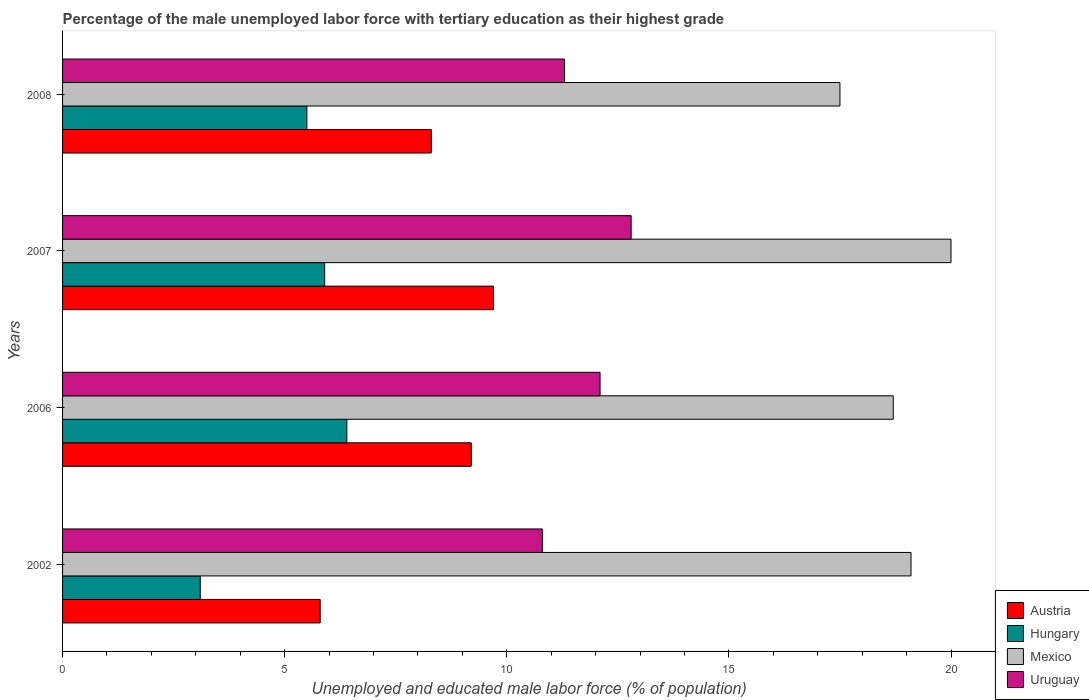How many groups of bars are there?
Keep it short and to the point. 4. Are the number of bars on each tick of the Y-axis equal?
Offer a very short reply. Yes. How many bars are there on the 4th tick from the bottom?
Your response must be concise. 4. What is the percentage of the unemployed male labor force with tertiary education in Hungary in 2007?
Offer a terse response. 5.9. Across all years, what is the maximum percentage of the unemployed male labor force with tertiary education in Uruguay?
Your answer should be very brief. 12.8. What is the difference between the percentage of the unemployed male labor force with tertiary education in Uruguay in 2007 and that in 2008?
Your response must be concise. 1.5. What is the difference between the percentage of the unemployed male labor force with tertiary education in Uruguay in 2008 and the percentage of the unemployed male labor force with tertiary education in Austria in 2007?
Offer a very short reply. 1.6. What is the average percentage of the unemployed male labor force with tertiary education in Mexico per year?
Give a very brief answer. 18.83. In the year 2006, what is the difference between the percentage of the unemployed male labor force with tertiary education in Uruguay and percentage of the unemployed male labor force with tertiary education in Hungary?
Your response must be concise. 5.7. What is the ratio of the percentage of the unemployed male labor force with tertiary education in Uruguay in 2002 to that in 2006?
Offer a terse response. 0.89. Is the percentage of the unemployed male labor force with tertiary education in Austria in 2002 less than that in 2007?
Ensure brevity in your answer.  Yes. What is the difference between the highest and the second highest percentage of the unemployed male labor force with tertiary education in Mexico?
Provide a short and direct response. 0.9. What is the difference between the highest and the lowest percentage of the unemployed male labor force with tertiary education in Hungary?
Give a very brief answer. 3.3. What does the 3rd bar from the top in 2006 represents?
Offer a terse response. Hungary. Is it the case that in every year, the sum of the percentage of the unemployed male labor force with tertiary education in Uruguay and percentage of the unemployed male labor force with tertiary education in Mexico is greater than the percentage of the unemployed male labor force with tertiary education in Austria?
Your answer should be compact. Yes. Are all the bars in the graph horizontal?
Keep it short and to the point. Yes. How many years are there in the graph?
Your response must be concise. 4. Does the graph contain any zero values?
Offer a very short reply. No. Does the graph contain grids?
Provide a short and direct response. No. Where does the legend appear in the graph?
Your response must be concise. Bottom right. How many legend labels are there?
Offer a very short reply. 4. How are the legend labels stacked?
Ensure brevity in your answer.  Vertical. What is the title of the graph?
Your answer should be compact. Percentage of the male unemployed labor force with tertiary education as their highest grade. Does "Gambia, The" appear as one of the legend labels in the graph?
Your answer should be compact. No. What is the label or title of the X-axis?
Offer a terse response. Unemployed and educated male labor force (% of population). What is the label or title of the Y-axis?
Make the answer very short. Years. What is the Unemployed and educated male labor force (% of population) in Austria in 2002?
Your response must be concise. 5.8. What is the Unemployed and educated male labor force (% of population) of Hungary in 2002?
Offer a terse response. 3.1. What is the Unemployed and educated male labor force (% of population) in Mexico in 2002?
Give a very brief answer. 19.1. What is the Unemployed and educated male labor force (% of population) of Uruguay in 2002?
Keep it short and to the point. 10.8. What is the Unemployed and educated male labor force (% of population) in Austria in 2006?
Provide a succinct answer. 9.2. What is the Unemployed and educated male labor force (% of population) in Hungary in 2006?
Offer a very short reply. 6.4. What is the Unemployed and educated male labor force (% of population) in Mexico in 2006?
Give a very brief answer. 18.7. What is the Unemployed and educated male labor force (% of population) in Uruguay in 2006?
Provide a succinct answer. 12.1. What is the Unemployed and educated male labor force (% of population) in Austria in 2007?
Offer a very short reply. 9.7. What is the Unemployed and educated male labor force (% of population) of Hungary in 2007?
Ensure brevity in your answer.  5.9. What is the Unemployed and educated male labor force (% of population) of Mexico in 2007?
Make the answer very short. 20. What is the Unemployed and educated male labor force (% of population) of Uruguay in 2007?
Offer a terse response. 12.8. What is the Unemployed and educated male labor force (% of population) in Austria in 2008?
Make the answer very short. 8.3. What is the Unemployed and educated male labor force (% of population) of Hungary in 2008?
Your answer should be compact. 5.5. What is the Unemployed and educated male labor force (% of population) of Mexico in 2008?
Make the answer very short. 17.5. What is the Unemployed and educated male labor force (% of population) in Uruguay in 2008?
Your answer should be very brief. 11.3. Across all years, what is the maximum Unemployed and educated male labor force (% of population) in Austria?
Provide a short and direct response. 9.7. Across all years, what is the maximum Unemployed and educated male labor force (% of population) in Hungary?
Offer a very short reply. 6.4. Across all years, what is the maximum Unemployed and educated male labor force (% of population) in Mexico?
Ensure brevity in your answer.  20. Across all years, what is the maximum Unemployed and educated male labor force (% of population) in Uruguay?
Provide a short and direct response. 12.8. Across all years, what is the minimum Unemployed and educated male labor force (% of population) in Austria?
Ensure brevity in your answer.  5.8. Across all years, what is the minimum Unemployed and educated male labor force (% of population) in Hungary?
Keep it short and to the point. 3.1. Across all years, what is the minimum Unemployed and educated male labor force (% of population) of Mexico?
Your answer should be compact. 17.5. Across all years, what is the minimum Unemployed and educated male labor force (% of population) of Uruguay?
Your answer should be very brief. 10.8. What is the total Unemployed and educated male labor force (% of population) of Hungary in the graph?
Keep it short and to the point. 20.9. What is the total Unemployed and educated male labor force (% of population) of Mexico in the graph?
Your response must be concise. 75.3. What is the total Unemployed and educated male labor force (% of population) of Uruguay in the graph?
Ensure brevity in your answer.  47. What is the difference between the Unemployed and educated male labor force (% of population) in Mexico in 2002 and that in 2006?
Offer a very short reply. 0.4. What is the difference between the Unemployed and educated male labor force (% of population) in Uruguay in 2002 and that in 2006?
Make the answer very short. -1.3. What is the difference between the Unemployed and educated male labor force (% of population) of Austria in 2002 and that in 2007?
Your answer should be very brief. -3.9. What is the difference between the Unemployed and educated male labor force (% of population) in Mexico in 2002 and that in 2007?
Your response must be concise. -0.9. What is the difference between the Unemployed and educated male labor force (% of population) in Austria in 2002 and that in 2008?
Your answer should be very brief. -2.5. What is the difference between the Unemployed and educated male labor force (% of population) of Hungary in 2002 and that in 2008?
Make the answer very short. -2.4. What is the difference between the Unemployed and educated male labor force (% of population) of Mexico in 2002 and that in 2008?
Your answer should be compact. 1.6. What is the difference between the Unemployed and educated male labor force (% of population) in Mexico in 2006 and that in 2007?
Your response must be concise. -1.3. What is the difference between the Unemployed and educated male labor force (% of population) of Uruguay in 2006 and that in 2007?
Provide a succinct answer. -0.7. What is the difference between the Unemployed and educated male labor force (% of population) in Hungary in 2006 and that in 2008?
Your answer should be very brief. 0.9. What is the difference between the Unemployed and educated male labor force (% of population) in Mexico in 2006 and that in 2008?
Ensure brevity in your answer.  1.2. What is the difference between the Unemployed and educated male labor force (% of population) of Austria in 2007 and that in 2008?
Make the answer very short. 1.4. What is the difference between the Unemployed and educated male labor force (% of population) in Mexico in 2007 and that in 2008?
Offer a very short reply. 2.5. What is the difference between the Unemployed and educated male labor force (% of population) of Uruguay in 2007 and that in 2008?
Give a very brief answer. 1.5. What is the difference between the Unemployed and educated male labor force (% of population) in Austria in 2002 and the Unemployed and educated male labor force (% of population) in Mexico in 2006?
Provide a short and direct response. -12.9. What is the difference between the Unemployed and educated male labor force (% of population) in Hungary in 2002 and the Unemployed and educated male labor force (% of population) in Mexico in 2006?
Your answer should be very brief. -15.6. What is the difference between the Unemployed and educated male labor force (% of population) of Austria in 2002 and the Unemployed and educated male labor force (% of population) of Hungary in 2007?
Provide a short and direct response. -0.1. What is the difference between the Unemployed and educated male labor force (% of population) of Hungary in 2002 and the Unemployed and educated male labor force (% of population) of Mexico in 2007?
Your answer should be compact. -16.9. What is the difference between the Unemployed and educated male labor force (% of population) in Hungary in 2002 and the Unemployed and educated male labor force (% of population) in Uruguay in 2007?
Your response must be concise. -9.7. What is the difference between the Unemployed and educated male labor force (% of population) in Mexico in 2002 and the Unemployed and educated male labor force (% of population) in Uruguay in 2007?
Your answer should be compact. 6.3. What is the difference between the Unemployed and educated male labor force (% of population) of Hungary in 2002 and the Unemployed and educated male labor force (% of population) of Mexico in 2008?
Provide a succinct answer. -14.4. What is the difference between the Unemployed and educated male labor force (% of population) of Hungary in 2002 and the Unemployed and educated male labor force (% of population) of Uruguay in 2008?
Ensure brevity in your answer.  -8.2. What is the difference between the Unemployed and educated male labor force (% of population) in Austria in 2006 and the Unemployed and educated male labor force (% of population) in Uruguay in 2007?
Provide a short and direct response. -3.6. What is the difference between the Unemployed and educated male labor force (% of population) of Hungary in 2006 and the Unemployed and educated male labor force (% of population) of Mexico in 2007?
Provide a short and direct response. -13.6. What is the difference between the Unemployed and educated male labor force (% of population) in Hungary in 2006 and the Unemployed and educated male labor force (% of population) in Uruguay in 2008?
Give a very brief answer. -4.9. What is the difference between the Unemployed and educated male labor force (% of population) in Mexico in 2006 and the Unemployed and educated male labor force (% of population) in Uruguay in 2008?
Your answer should be very brief. 7.4. What is the difference between the Unemployed and educated male labor force (% of population) in Austria in 2007 and the Unemployed and educated male labor force (% of population) in Hungary in 2008?
Offer a terse response. 4.2. What is the difference between the Unemployed and educated male labor force (% of population) of Austria in 2007 and the Unemployed and educated male labor force (% of population) of Mexico in 2008?
Provide a short and direct response. -7.8. What is the difference between the Unemployed and educated male labor force (% of population) of Hungary in 2007 and the Unemployed and educated male labor force (% of population) of Uruguay in 2008?
Your answer should be compact. -5.4. What is the difference between the Unemployed and educated male labor force (% of population) of Mexico in 2007 and the Unemployed and educated male labor force (% of population) of Uruguay in 2008?
Offer a terse response. 8.7. What is the average Unemployed and educated male labor force (% of population) of Austria per year?
Make the answer very short. 8.25. What is the average Unemployed and educated male labor force (% of population) in Hungary per year?
Offer a terse response. 5.22. What is the average Unemployed and educated male labor force (% of population) of Mexico per year?
Ensure brevity in your answer.  18.82. What is the average Unemployed and educated male labor force (% of population) in Uruguay per year?
Provide a succinct answer. 11.75. In the year 2002, what is the difference between the Unemployed and educated male labor force (% of population) of Austria and Unemployed and educated male labor force (% of population) of Uruguay?
Ensure brevity in your answer.  -5. In the year 2002, what is the difference between the Unemployed and educated male labor force (% of population) of Mexico and Unemployed and educated male labor force (% of population) of Uruguay?
Offer a terse response. 8.3. In the year 2006, what is the difference between the Unemployed and educated male labor force (% of population) in Austria and Unemployed and educated male labor force (% of population) in Mexico?
Ensure brevity in your answer.  -9.5. In the year 2006, what is the difference between the Unemployed and educated male labor force (% of population) in Hungary and Unemployed and educated male labor force (% of population) in Uruguay?
Your response must be concise. -5.7. In the year 2006, what is the difference between the Unemployed and educated male labor force (% of population) of Mexico and Unemployed and educated male labor force (% of population) of Uruguay?
Your answer should be compact. 6.6. In the year 2007, what is the difference between the Unemployed and educated male labor force (% of population) of Austria and Unemployed and educated male labor force (% of population) of Hungary?
Your answer should be very brief. 3.8. In the year 2007, what is the difference between the Unemployed and educated male labor force (% of population) in Austria and Unemployed and educated male labor force (% of population) in Mexico?
Provide a short and direct response. -10.3. In the year 2007, what is the difference between the Unemployed and educated male labor force (% of population) in Hungary and Unemployed and educated male labor force (% of population) in Mexico?
Your answer should be very brief. -14.1. In the year 2007, what is the difference between the Unemployed and educated male labor force (% of population) of Hungary and Unemployed and educated male labor force (% of population) of Uruguay?
Make the answer very short. -6.9. In the year 2008, what is the difference between the Unemployed and educated male labor force (% of population) of Austria and Unemployed and educated male labor force (% of population) of Mexico?
Provide a succinct answer. -9.2. In the year 2008, what is the difference between the Unemployed and educated male labor force (% of population) of Hungary and Unemployed and educated male labor force (% of population) of Mexico?
Give a very brief answer. -12. In the year 2008, what is the difference between the Unemployed and educated male labor force (% of population) of Hungary and Unemployed and educated male labor force (% of population) of Uruguay?
Give a very brief answer. -5.8. What is the ratio of the Unemployed and educated male labor force (% of population) of Austria in 2002 to that in 2006?
Keep it short and to the point. 0.63. What is the ratio of the Unemployed and educated male labor force (% of population) in Hungary in 2002 to that in 2006?
Offer a very short reply. 0.48. What is the ratio of the Unemployed and educated male labor force (% of population) of Mexico in 2002 to that in 2006?
Keep it short and to the point. 1.02. What is the ratio of the Unemployed and educated male labor force (% of population) of Uruguay in 2002 to that in 2006?
Make the answer very short. 0.89. What is the ratio of the Unemployed and educated male labor force (% of population) of Austria in 2002 to that in 2007?
Give a very brief answer. 0.6. What is the ratio of the Unemployed and educated male labor force (% of population) in Hungary in 2002 to that in 2007?
Your response must be concise. 0.53. What is the ratio of the Unemployed and educated male labor force (% of population) in Mexico in 2002 to that in 2007?
Your answer should be very brief. 0.95. What is the ratio of the Unemployed and educated male labor force (% of population) in Uruguay in 2002 to that in 2007?
Your answer should be compact. 0.84. What is the ratio of the Unemployed and educated male labor force (% of population) in Austria in 2002 to that in 2008?
Your answer should be very brief. 0.7. What is the ratio of the Unemployed and educated male labor force (% of population) in Hungary in 2002 to that in 2008?
Your answer should be very brief. 0.56. What is the ratio of the Unemployed and educated male labor force (% of population) in Mexico in 2002 to that in 2008?
Provide a succinct answer. 1.09. What is the ratio of the Unemployed and educated male labor force (% of population) of Uruguay in 2002 to that in 2008?
Ensure brevity in your answer.  0.96. What is the ratio of the Unemployed and educated male labor force (% of population) in Austria in 2006 to that in 2007?
Provide a succinct answer. 0.95. What is the ratio of the Unemployed and educated male labor force (% of population) of Hungary in 2006 to that in 2007?
Offer a terse response. 1.08. What is the ratio of the Unemployed and educated male labor force (% of population) in Mexico in 2006 to that in 2007?
Keep it short and to the point. 0.94. What is the ratio of the Unemployed and educated male labor force (% of population) in Uruguay in 2006 to that in 2007?
Ensure brevity in your answer.  0.95. What is the ratio of the Unemployed and educated male labor force (% of population) in Austria in 2006 to that in 2008?
Provide a short and direct response. 1.11. What is the ratio of the Unemployed and educated male labor force (% of population) in Hungary in 2006 to that in 2008?
Give a very brief answer. 1.16. What is the ratio of the Unemployed and educated male labor force (% of population) of Mexico in 2006 to that in 2008?
Ensure brevity in your answer.  1.07. What is the ratio of the Unemployed and educated male labor force (% of population) of Uruguay in 2006 to that in 2008?
Offer a terse response. 1.07. What is the ratio of the Unemployed and educated male labor force (% of population) of Austria in 2007 to that in 2008?
Your answer should be compact. 1.17. What is the ratio of the Unemployed and educated male labor force (% of population) of Hungary in 2007 to that in 2008?
Your answer should be compact. 1.07. What is the ratio of the Unemployed and educated male labor force (% of population) in Mexico in 2007 to that in 2008?
Offer a very short reply. 1.14. What is the ratio of the Unemployed and educated male labor force (% of population) in Uruguay in 2007 to that in 2008?
Provide a short and direct response. 1.13. What is the difference between the highest and the second highest Unemployed and educated male labor force (% of population) in Austria?
Provide a short and direct response. 0.5. What is the difference between the highest and the second highest Unemployed and educated male labor force (% of population) of Hungary?
Make the answer very short. 0.5. What is the difference between the highest and the second highest Unemployed and educated male labor force (% of population) in Mexico?
Your response must be concise. 0.9. What is the difference between the highest and the second highest Unemployed and educated male labor force (% of population) in Uruguay?
Offer a very short reply. 0.7. What is the difference between the highest and the lowest Unemployed and educated male labor force (% of population) in Austria?
Your response must be concise. 3.9. What is the difference between the highest and the lowest Unemployed and educated male labor force (% of population) in Mexico?
Keep it short and to the point. 2.5. What is the difference between the highest and the lowest Unemployed and educated male labor force (% of population) in Uruguay?
Ensure brevity in your answer.  2. 